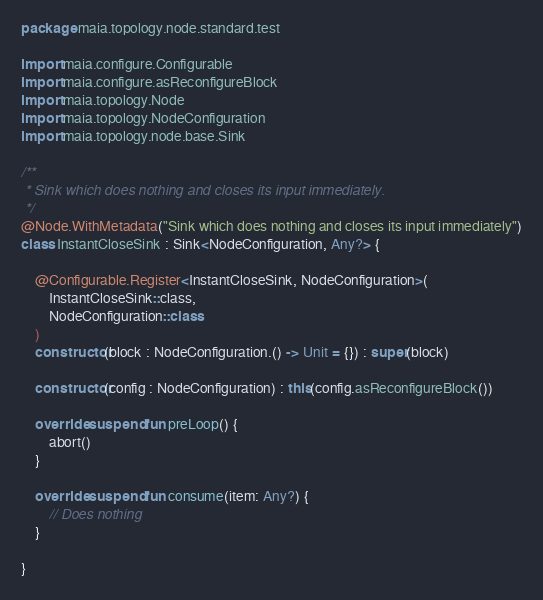Convert code to text. <code><loc_0><loc_0><loc_500><loc_500><_Kotlin_>package maia.topology.node.standard.test

import maia.configure.Configurable
import maia.configure.asReconfigureBlock
import maia.topology.Node
import maia.topology.NodeConfiguration
import maia.topology.node.base.Sink

/**
 * Sink which does nothing and closes its input immediately.
 */
@Node.WithMetadata("Sink which does nothing and closes its input immediately")
class InstantCloseSink : Sink<NodeConfiguration, Any?> {

    @Configurable.Register<InstantCloseSink, NodeConfiguration>(
        InstantCloseSink::class,
        NodeConfiguration::class
    )
    constructor(block : NodeConfiguration.() -> Unit = {}) : super(block)

    constructor(config : NodeConfiguration) : this(config.asReconfigureBlock())

    override suspend fun preLoop() {
        abort()
    }

    override suspend fun consume(item: Any?) {
        // Does nothing
    }

}
</code> 